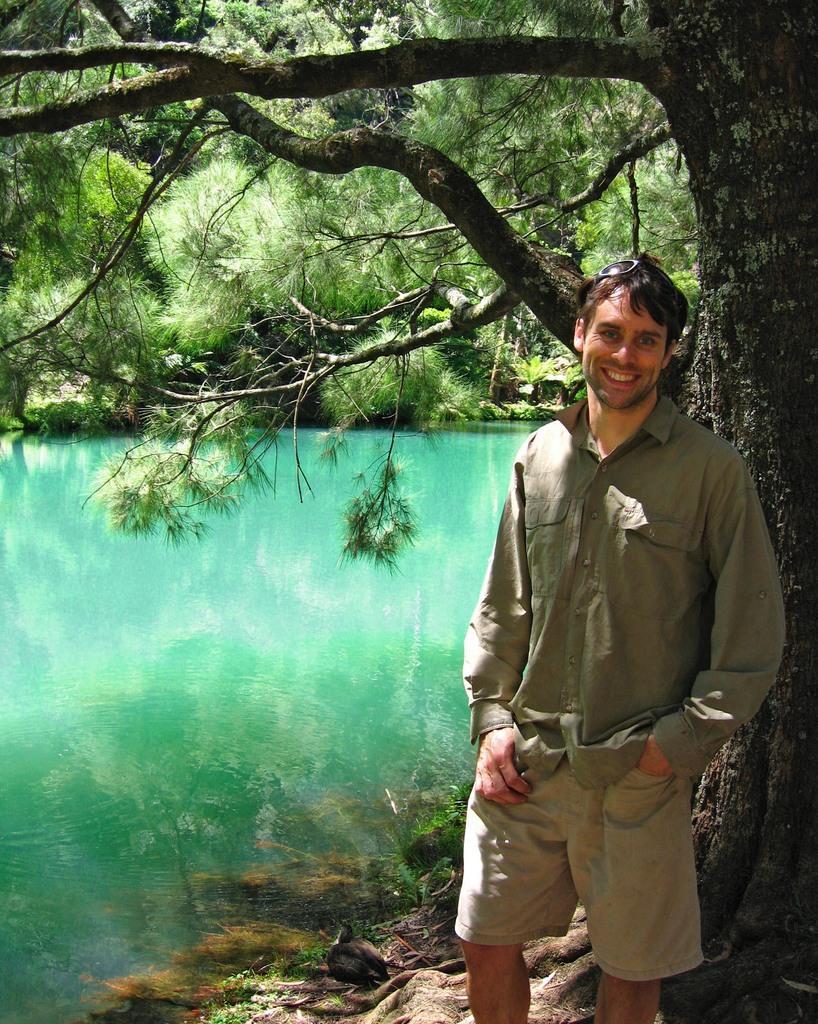Please provide a concise description of this image. In this image we can see a man standing on the ground, lake and trees. 